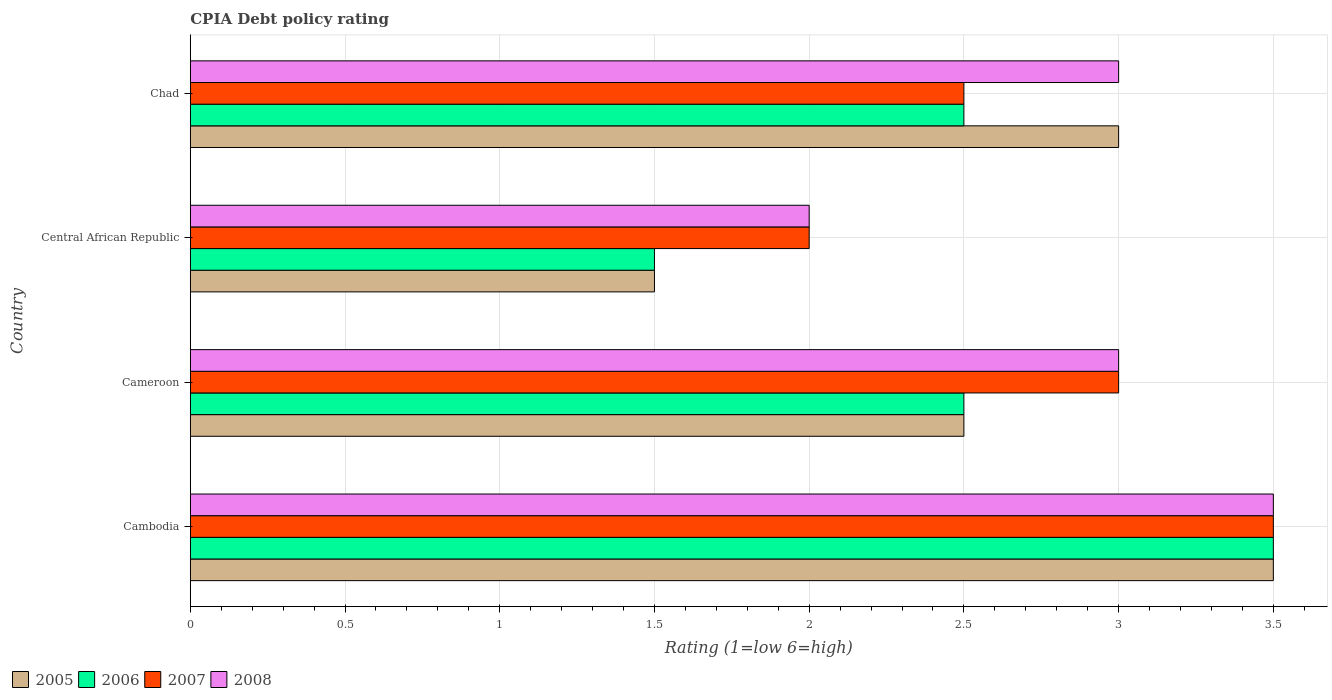How many different coloured bars are there?
Make the answer very short. 4. How many groups of bars are there?
Provide a succinct answer. 4. Are the number of bars per tick equal to the number of legend labels?
Offer a very short reply. Yes. How many bars are there on the 1st tick from the top?
Give a very brief answer. 4. What is the label of the 1st group of bars from the top?
Offer a terse response. Chad. What is the CPIA rating in 2008 in Chad?
Make the answer very short. 3. Across all countries, what is the maximum CPIA rating in 2006?
Ensure brevity in your answer.  3.5. Across all countries, what is the minimum CPIA rating in 2007?
Your answer should be compact. 2. In which country was the CPIA rating in 2008 maximum?
Ensure brevity in your answer.  Cambodia. In which country was the CPIA rating in 2006 minimum?
Offer a very short reply. Central African Republic. What is the total CPIA rating in 2007 in the graph?
Offer a very short reply. 11. What is the difference between the CPIA rating in 2005 in Chad and the CPIA rating in 2006 in Cameroon?
Your response must be concise. 0.5. What is the average CPIA rating in 2005 per country?
Give a very brief answer. 2.62. What is the ratio of the CPIA rating in 2005 in Cambodia to that in Cameroon?
Your answer should be compact. 1.4. Is the difference between the CPIA rating in 2008 in Cameroon and Chad greater than the difference between the CPIA rating in 2007 in Cameroon and Chad?
Your response must be concise. No. What is the difference between the highest and the lowest CPIA rating in 2008?
Make the answer very short. 1.5. In how many countries, is the CPIA rating in 2006 greater than the average CPIA rating in 2006 taken over all countries?
Keep it short and to the point. 1. Is it the case that in every country, the sum of the CPIA rating in 2008 and CPIA rating in 2005 is greater than the CPIA rating in 2006?
Make the answer very short. Yes. How many bars are there?
Make the answer very short. 16. Are all the bars in the graph horizontal?
Offer a terse response. Yes. How many countries are there in the graph?
Ensure brevity in your answer.  4. What is the difference between two consecutive major ticks on the X-axis?
Give a very brief answer. 0.5. Are the values on the major ticks of X-axis written in scientific E-notation?
Offer a terse response. No. Does the graph contain any zero values?
Make the answer very short. No. Where does the legend appear in the graph?
Your answer should be very brief. Bottom left. How are the legend labels stacked?
Your answer should be very brief. Horizontal. What is the title of the graph?
Give a very brief answer. CPIA Debt policy rating. What is the label or title of the Y-axis?
Make the answer very short. Country. What is the Rating (1=low 6=high) in 2005 in Cambodia?
Your answer should be very brief. 3.5. What is the Rating (1=low 6=high) of 2006 in Cameroon?
Offer a very short reply. 2.5. What is the Rating (1=low 6=high) of 2007 in Cameroon?
Offer a very short reply. 3. What is the Rating (1=low 6=high) in 2008 in Cameroon?
Make the answer very short. 3. What is the Rating (1=low 6=high) in 2006 in Central African Republic?
Your answer should be compact. 1.5. What is the Rating (1=low 6=high) of 2005 in Chad?
Ensure brevity in your answer.  3. What is the Rating (1=low 6=high) in 2006 in Chad?
Your answer should be compact. 2.5. What is the Rating (1=low 6=high) in 2007 in Chad?
Offer a terse response. 2.5. What is the Rating (1=low 6=high) of 2008 in Chad?
Offer a terse response. 3. Across all countries, what is the maximum Rating (1=low 6=high) of 2005?
Keep it short and to the point. 3.5. Across all countries, what is the maximum Rating (1=low 6=high) of 2006?
Offer a terse response. 3.5. Across all countries, what is the maximum Rating (1=low 6=high) in 2008?
Give a very brief answer. 3.5. Across all countries, what is the minimum Rating (1=low 6=high) in 2005?
Your response must be concise. 1.5. Across all countries, what is the minimum Rating (1=low 6=high) in 2007?
Offer a very short reply. 2. What is the total Rating (1=low 6=high) of 2005 in the graph?
Your answer should be compact. 10.5. What is the total Rating (1=low 6=high) in 2006 in the graph?
Keep it short and to the point. 10. What is the total Rating (1=low 6=high) in 2008 in the graph?
Provide a short and direct response. 11.5. What is the difference between the Rating (1=low 6=high) in 2006 in Cambodia and that in Cameroon?
Offer a terse response. 1. What is the difference between the Rating (1=low 6=high) of 2007 in Cambodia and that in Cameroon?
Your answer should be very brief. 0.5. What is the difference between the Rating (1=low 6=high) of 2005 in Cambodia and that in Chad?
Keep it short and to the point. 0.5. What is the difference between the Rating (1=low 6=high) of 2007 in Cambodia and that in Chad?
Offer a very short reply. 1. What is the difference between the Rating (1=low 6=high) in 2006 in Cameroon and that in Central African Republic?
Provide a succinct answer. 1. What is the difference between the Rating (1=low 6=high) of 2007 in Cameroon and that in Central African Republic?
Provide a short and direct response. 1. What is the difference between the Rating (1=low 6=high) in 2008 in Cameroon and that in Central African Republic?
Offer a terse response. 1. What is the difference between the Rating (1=low 6=high) in 2008 in Cameroon and that in Chad?
Your response must be concise. 0. What is the difference between the Rating (1=low 6=high) in 2006 in Central African Republic and that in Chad?
Provide a succinct answer. -1. What is the difference between the Rating (1=low 6=high) of 2007 in Central African Republic and that in Chad?
Give a very brief answer. -0.5. What is the difference between the Rating (1=low 6=high) in 2006 in Cambodia and the Rating (1=low 6=high) in 2007 in Cameroon?
Make the answer very short. 0.5. What is the difference between the Rating (1=low 6=high) in 2007 in Cambodia and the Rating (1=low 6=high) in 2008 in Central African Republic?
Offer a terse response. 1.5. What is the difference between the Rating (1=low 6=high) of 2005 in Cambodia and the Rating (1=low 6=high) of 2006 in Chad?
Ensure brevity in your answer.  1. What is the difference between the Rating (1=low 6=high) in 2005 in Cambodia and the Rating (1=low 6=high) in 2007 in Chad?
Your answer should be compact. 1. What is the difference between the Rating (1=low 6=high) of 2006 in Cambodia and the Rating (1=low 6=high) of 2007 in Chad?
Your response must be concise. 1. What is the difference between the Rating (1=low 6=high) of 2005 in Cameroon and the Rating (1=low 6=high) of 2007 in Chad?
Your answer should be compact. 0. What is the difference between the Rating (1=low 6=high) of 2005 in Cameroon and the Rating (1=low 6=high) of 2008 in Chad?
Your answer should be compact. -0.5. What is the difference between the Rating (1=low 6=high) in 2005 in Central African Republic and the Rating (1=low 6=high) in 2006 in Chad?
Offer a terse response. -1. What is the difference between the Rating (1=low 6=high) in 2005 in Central African Republic and the Rating (1=low 6=high) in 2008 in Chad?
Give a very brief answer. -1.5. What is the difference between the Rating (1=low 6=high) in 2006 in Central African Republic and the Rating (1=low 6=high) in 2007 in Chad?
Make the answer very short. -1. What is the difference between the Rating (1=low 6=high) of 2006 in Central African Republic and the Rating (1=low 6=high) of 2008 in Chad?
Make the answer very short. -1.5. What is the difference between the Rating (1=low 6=high) in 2007 in Central African Republic and the Rating (1=low 6=high) in 2008 in Chad?
Your answer should be compact. -1. What is the average Rating (1=low 6=high) of 2005 per country?
Offer a very short reply. 2.62. What is the average Rating (1=low 6=high) in 2006 per country?
Make the answer very short. 2.5. What is the average Rating (1=low 6=high) in 2007 per country?
Your response must be concise. 2.75. What is the average Rating (1=low 6=high) of 2008 per country?
Offer a very short reply. 2.88. What is the difference between the Rating (1=low 6=high) in 2006 and Rating (1=low 6=high) in 2007 in Cambodia?
Your answer should be compact. 0. What is the difference between the Rating (1=low 6=high) in 2006 and Rating (1=low 6=high) in 2008 in Cambodia?
Give a very brief answer. 0. What is the difference between the Rating (1=low 6=high) in 2007 and Rating (1=low 6=high) in 2008 in Cambodia?
Keep it short and to the point. 0. What is the difference between the Rating (1=low 6=high) of 2005 and Rating (1=low 6=high) of 2006 in Cameroon?
Make the answer very short. 0. What is the difference between the Rating (1=low 6=high) of 2005 and Rating (1=low 6=high) of 2007 in Cameroon?
Provide a short and direct response. -0.5. What is the difference between the Rating (1=low 6=high) in 2005 and Rating (1=low 6=high) in 2008 in Cameroon?
Provide a succinct answer. -0.5. What is the difference between the Rating (1=low 6=high) in 2007 and Rating (1=low 6=high) in 2008 in Cameroon?
Ensure brevity in your answer.  0. What is the difference between the Rating (1=low 6=high) of 2005 and Rating (1=low 6=high) of 2008 in Central African Republic?
Your answer should be very brief. -0.5. What is the difference between the Rating (1=low 6=high) of 2006 and Rating (1=low 6=high) of 2008 in Central African Republic?
Provide a short and direct response. -0.5. What is the difference between the Rating (1=low 6=high) of 2005 and Rating (1=low 6=high) of 2006 in Chad?
Give a very brief answer. 0.5. What is the difference between the Rating (1=low 6=high) in 2007 and Rating (1=low 6=high) in 2008 in Chad?
Offer a terse response. -0.5. What is the ratio of the Rating (1=low 6=high) of 2006 in Cambodia to that in Cameroon?
Give a very brief answer. 1.4. What is the ratio of the Rating (1=low 6=high) of 2005 in Cambodia to that in Central African Republic?
Make the answer very short. 2.33. What is the ratio of the Rating (1=low 6=high) of 2006 in Cambodia to that in Central African Republic?
Provide a short and direct response. 2.33. What is the ratio of the Rating (1=low 6=high) of 2005 in Cambodia to that in Chad?
Ensure brevity in your answer.  1.17. What is the ratio of the Rating (1=low 6=high) in 2006 in Cambodia to that in Chad?
Ensure brevity in your answer.  1.4. What is the ratio of the Rating (1=low 6=high) in 2008 in Cambodia to that in Chad?
Keep it short and to the point. 1.17. What is the ratio of the Rating (1=low 6=high) in 2008 in Cameroon to that in Central African Republic?
Keep it short and to the point. 1.5. What is the ratio of the Rating (1=low 6=high) in 2007 in Cameroon to that in Chad?
Make the answer very short. 1.2. What is the ratio of the Rating (1=low 6=high) of 2005 in Central African Republic to that in Chad?
Make the answer very short. 0.5. What is the ratio of the Rating (1=low 6=high) of 2006 in Central African Republic to that in Chad?
Your response must be concise. 0.6. What is the difference between the highest and the second highest Rating (1=low 6=high) of 2006?
Provide a succinct answer. 1. What is the difference between the highest and the second highest Rating (1=low 6=high) in 2007?
Offer a very short reply. 0.5. What is the difference between the highest and the lowest Rating (1=low 6=high) in 2006?
Keep it short and to the point. 2. What is the difference between the highest and the lowest Rating (1=low 6=high) of 2008?
Your answer should be very brief. 1.5. 